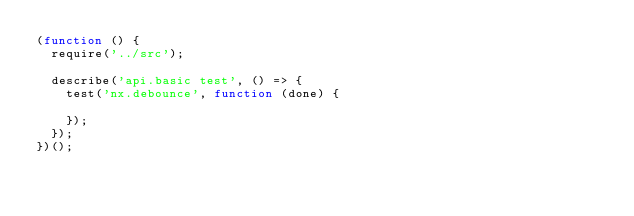Convert code to text. <code><loc_0><loc_0><loc_500><loc_500><_JavaScript_>(function () {
  require('../src');

  describe('api.basic test', () => {
    test('nx.debounce', function (done) {

    });
  });
})();
</code> 